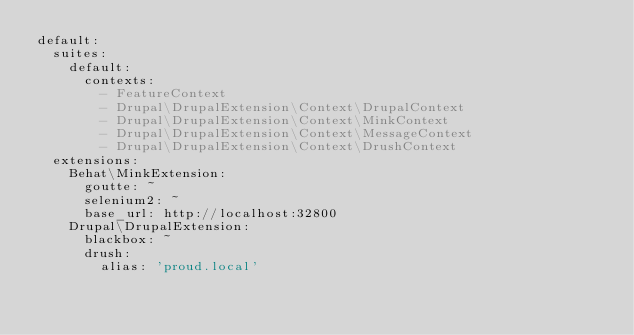Convert code to text. <code><loc_0><loc_0><loc_500><loc_500><_YAML_>default:
  suites:
    default:
      contexts:
        - FeatureContext
        - Drupal\DrupalExtension\Context\DrupalContext
        - Drupal\DrupalExtension\Context\MinkContext
        - Drupal\DrupalExtension\Context\MessageContext
        - Drupal\DrupalExtension\Context\DrushContext
  extensions:
    Behat\MinkExtension:
      goutte: ~
      selenium2: ~
      base_url: http://localhost:32800
    Drupal\DrupalExtension:
      blackbox: ~
      drush:
        alias: 'proud.local'
</code> 